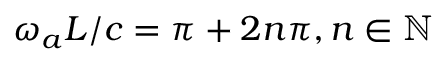Convert formula to latex. <formula><loc_0><loc_0><loc_500><loc_500>\omega _ { a } L / c = \pi + 2 n \pi , n \in \mathbb { N }</formula> 